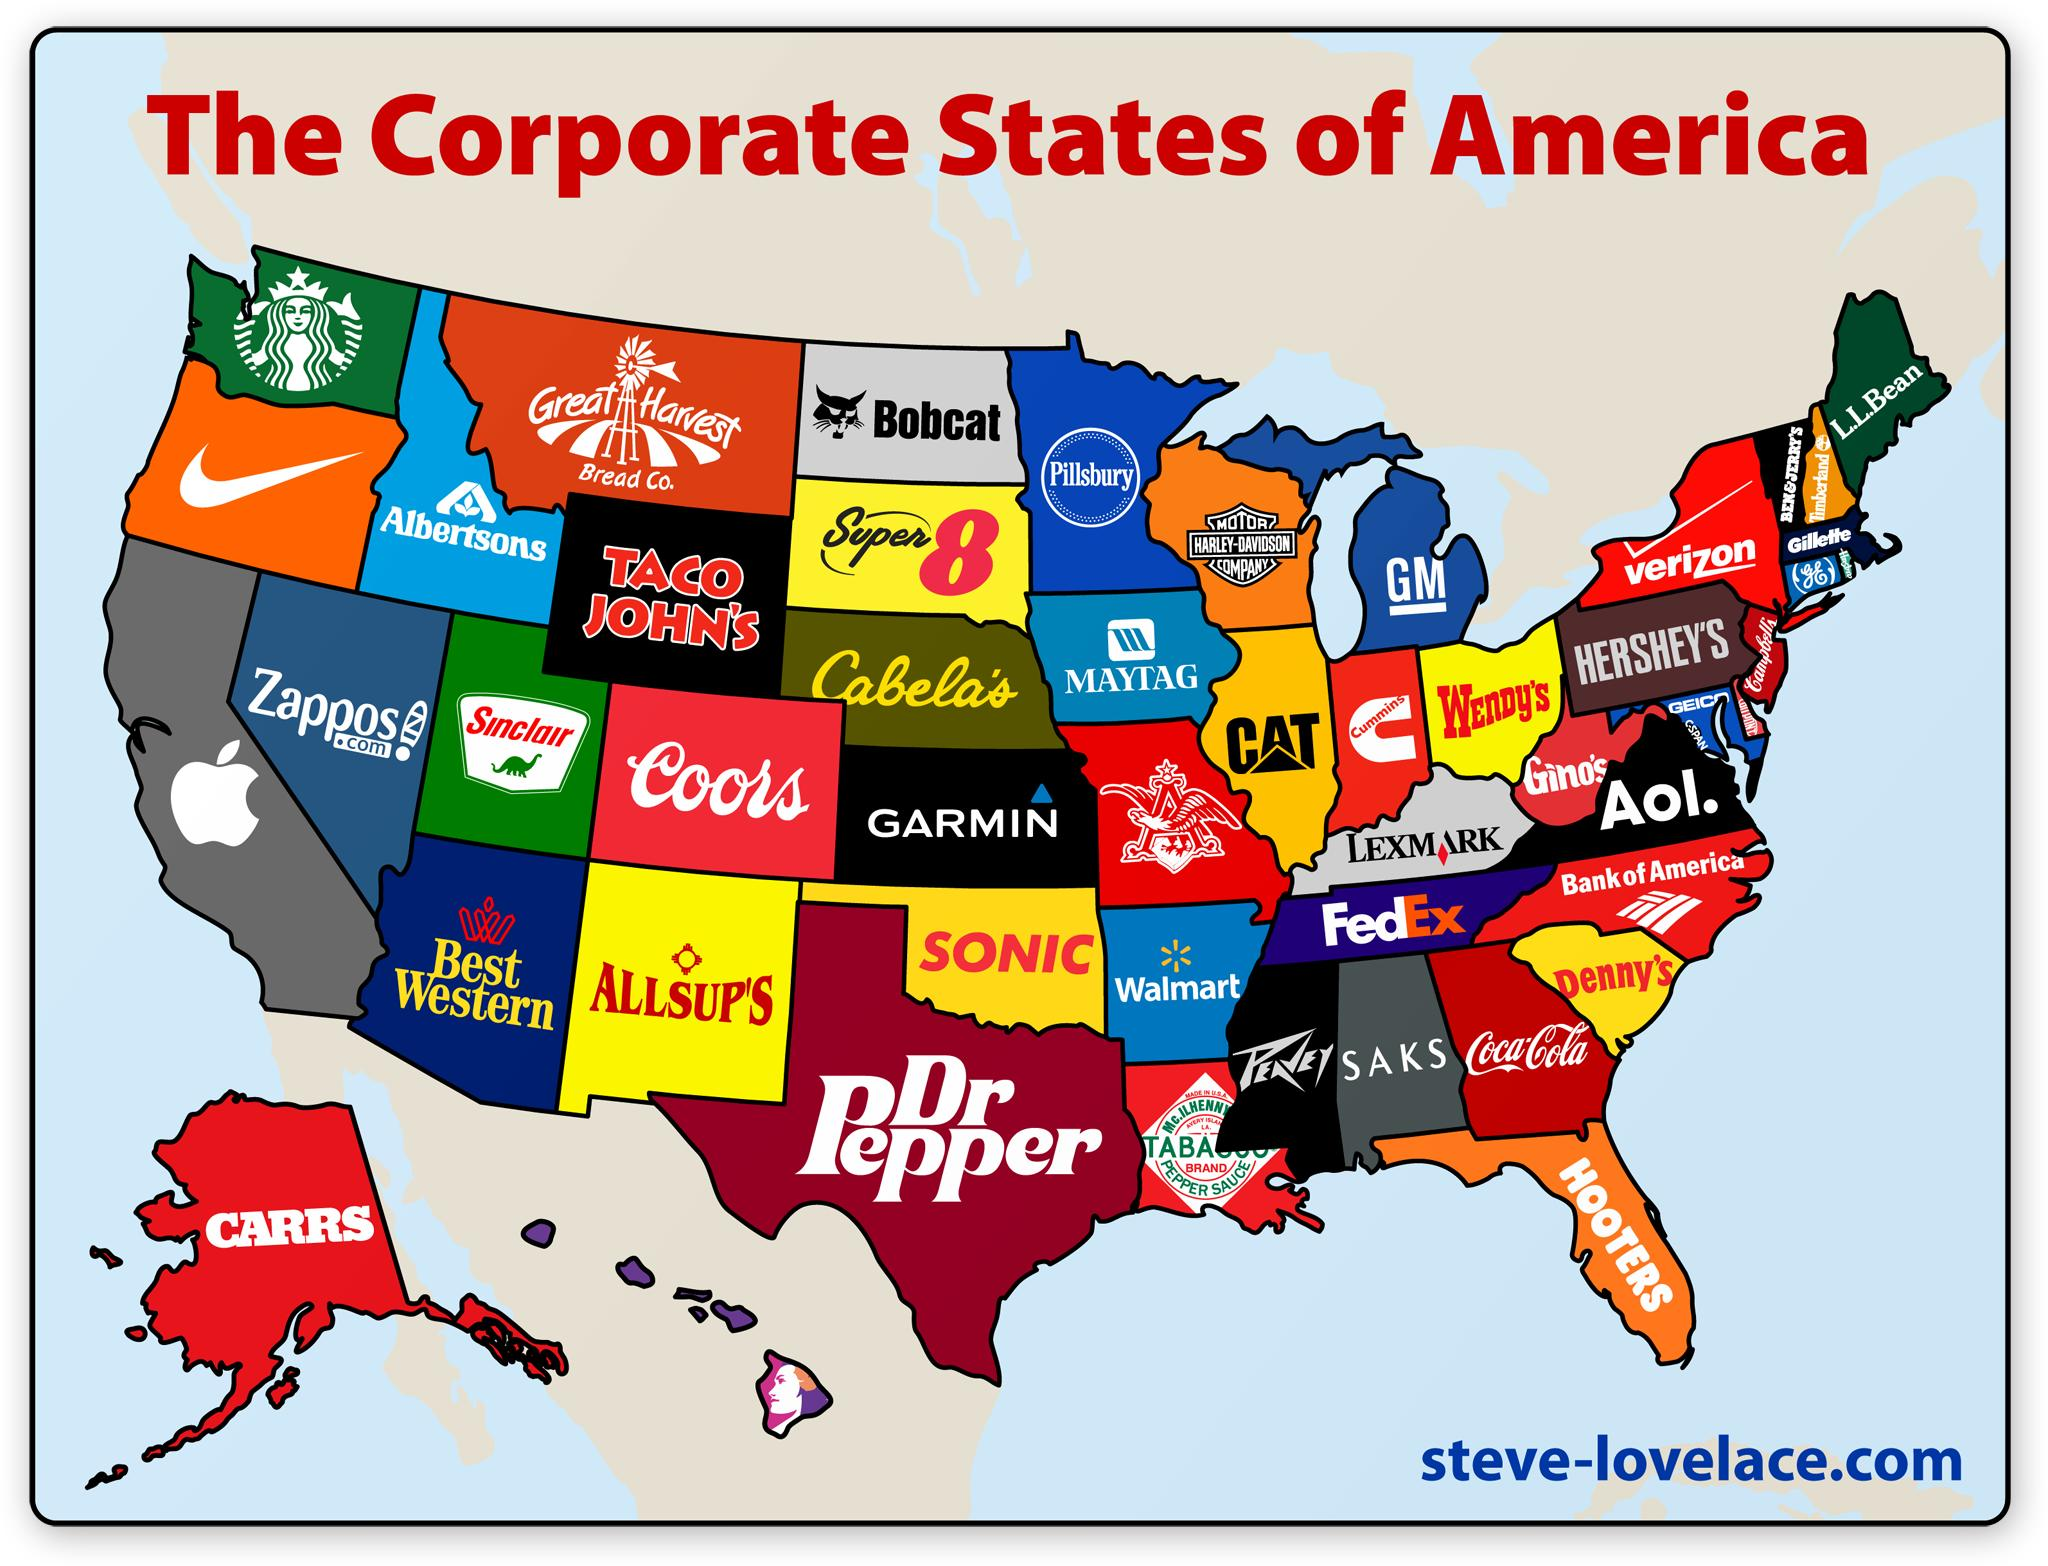Mention a couple of crucial points in this snapshot. There are five logos that have a black background. Out of the logos that have a green background color, three of them are present. The color of the logo of Verizon is red and white. 